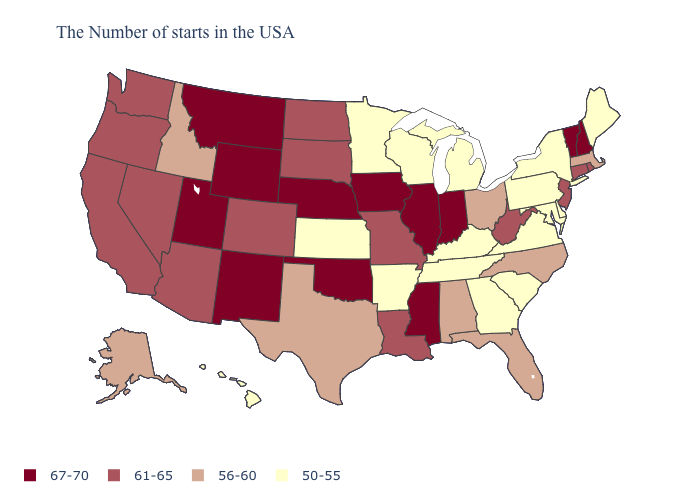What is the value of Utah?
Give a very brief answer. 67-70. Name the states that have a value in the range 50-55?
Be succinct. Maine, New York, Delaware, Maryland, Pennsylvania, Virginia, South Carolina, Georgia, Michigan, Kentucky, Tennessee, Wisconsin, Arkansas, Minnesota, Kansas, Hawaii. Name the states that have a value in the range 56-60?
Answer briefly. Massachusetts, North Carolina, Ohio, Florida, Alabama, Texas, Idaho, Alaska. Among the states that border Utah , does Arizona have the lowest value?
Short answer required. No. Among the states that border New Mexico , which have the lowest value?
Short answer required. Texas. What is the lowest value in states that border Indiana?
Give a very brief answer. 50-55. What is the value of Vermont?
Quick response, please. 67-70. What is the value of Illinois?
Answer briefly. 67-70. What is the lowest value in the Northeast?
Be succinct. 50-55. Does Michigan have the lowest value in the MidWest?
Concise answer only. Yes. Among the states that border New Hampshire , which have the highest value?
Short answer required. Vermont. What is the value of Kentucky?
Keep it brief. 50-55. Which states have the highest value in the USA?
Answer briefly. New Hampshire, Vermont, Indiana, Illinois, Mississippi, Iowa, Nebraska, Oklahoma, Wyoming, New Mexico, Utah, Montana. Among the states that border Kentucky , does Tennessee have the highest value?
Give a very brief answer. No. 